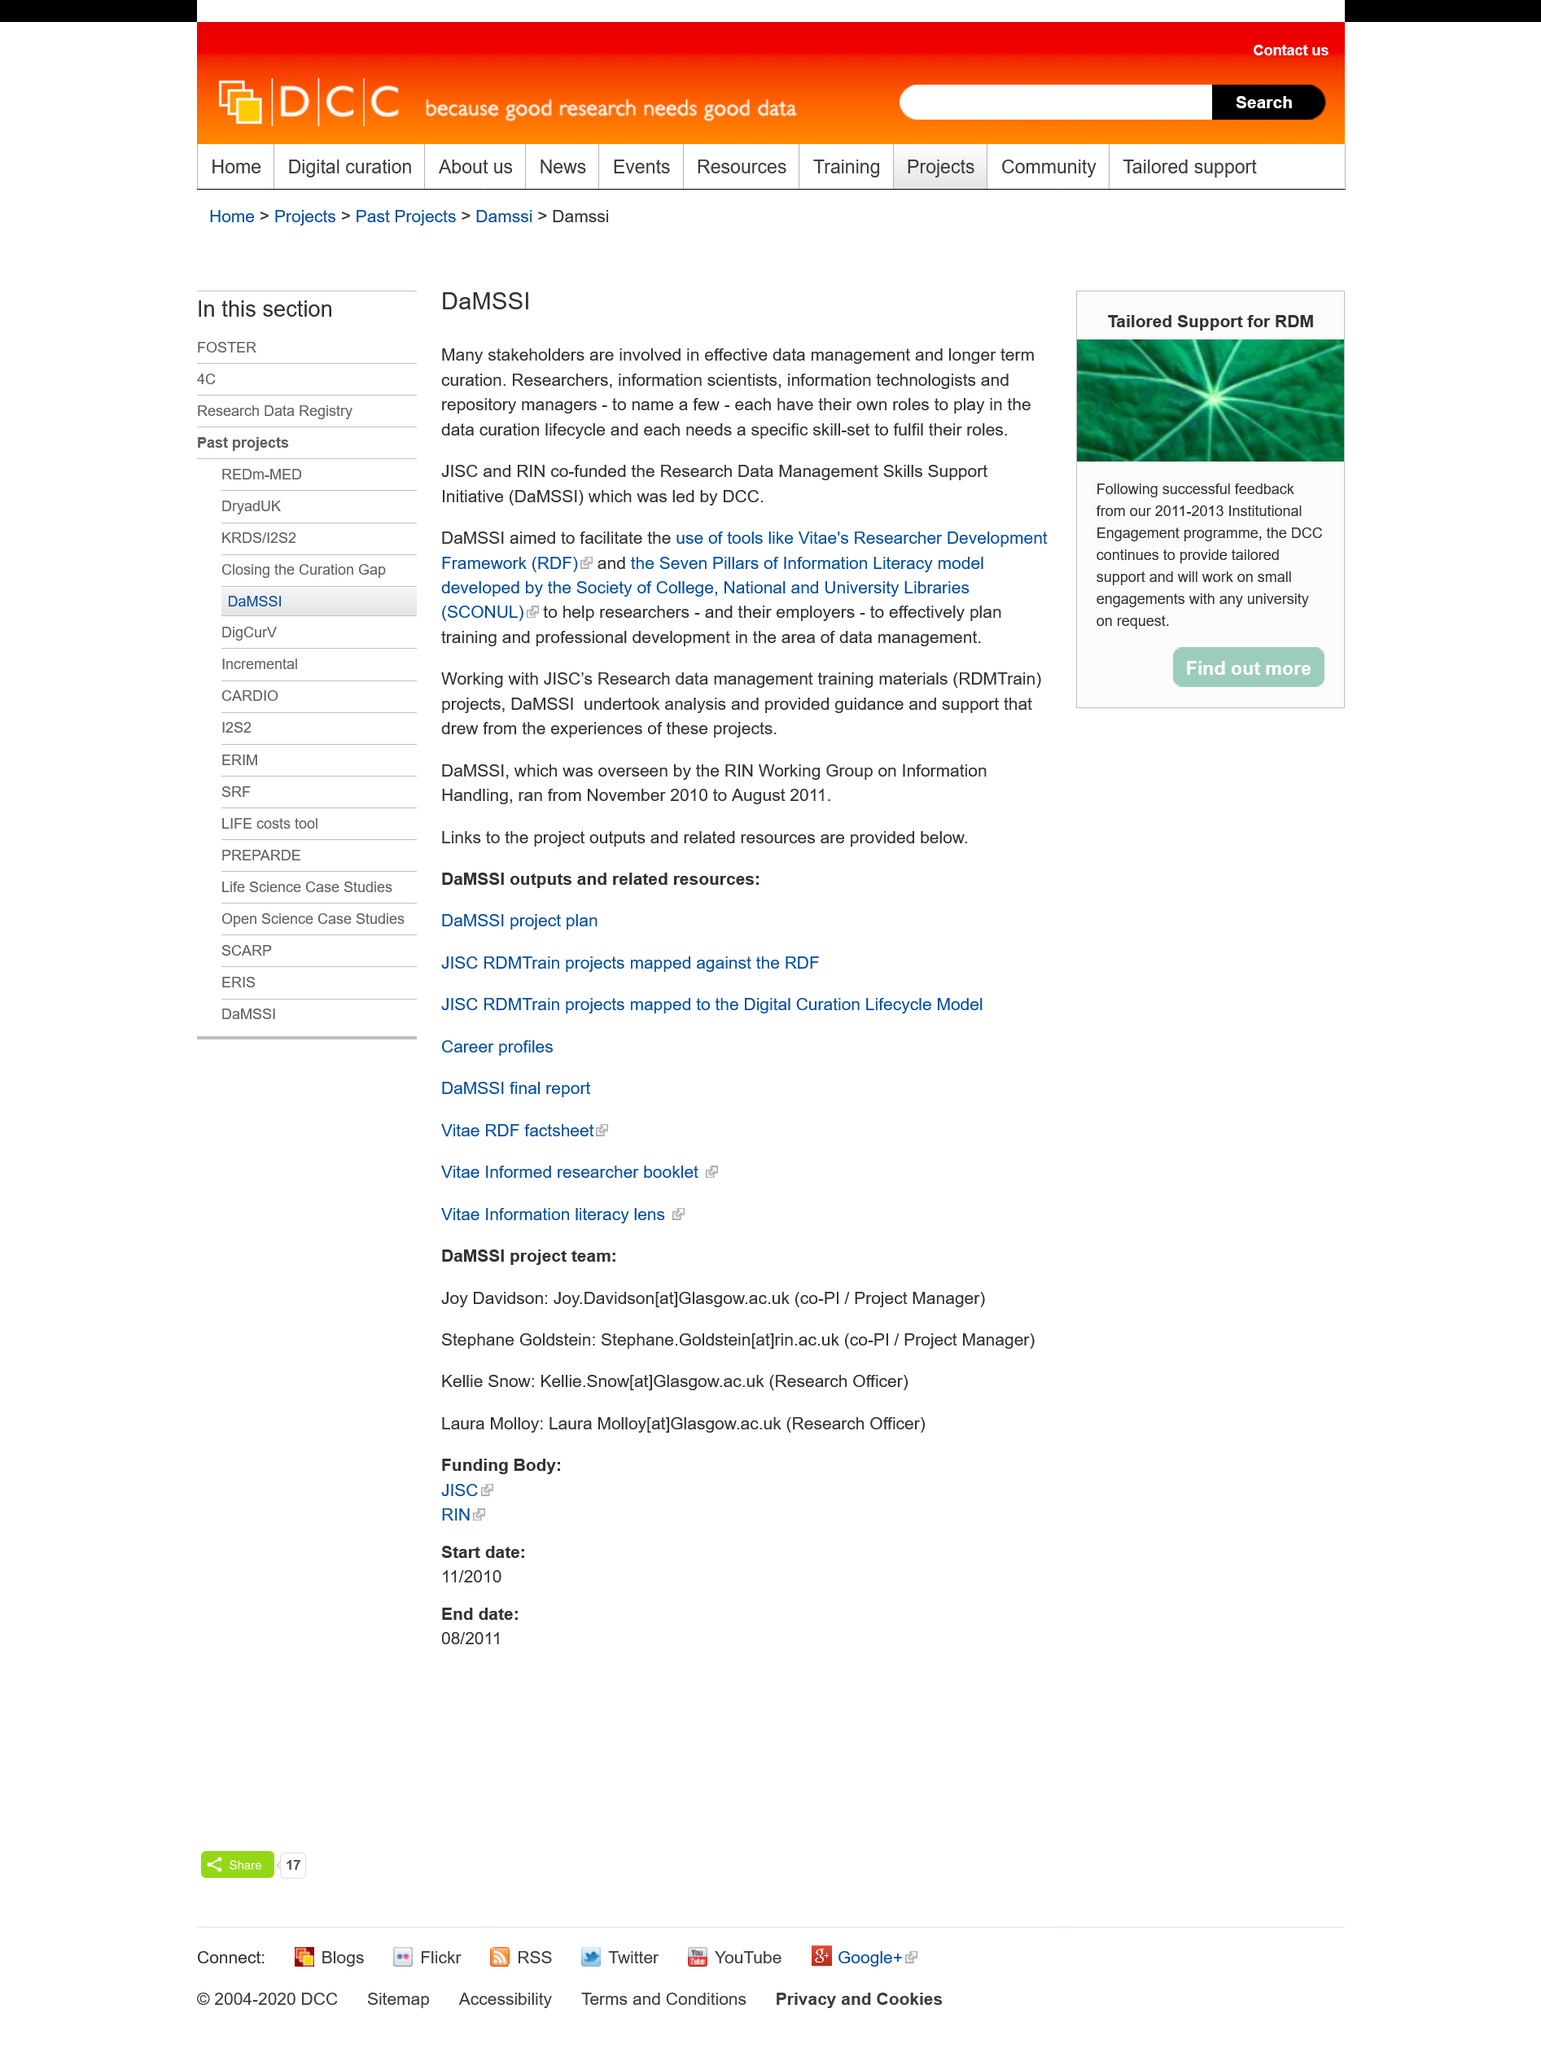Mention a couple of crucial points in this snapshot. The Society of College, National and University Libraries is commonly referred to by its acronym, SCONUL. DaMSSI stands for the Research Data Management Skills Support Initiative, which provides support for individuals to develop and enhance their skills in managing research data. The acronym RDF stands for Researcher Development Framework. 